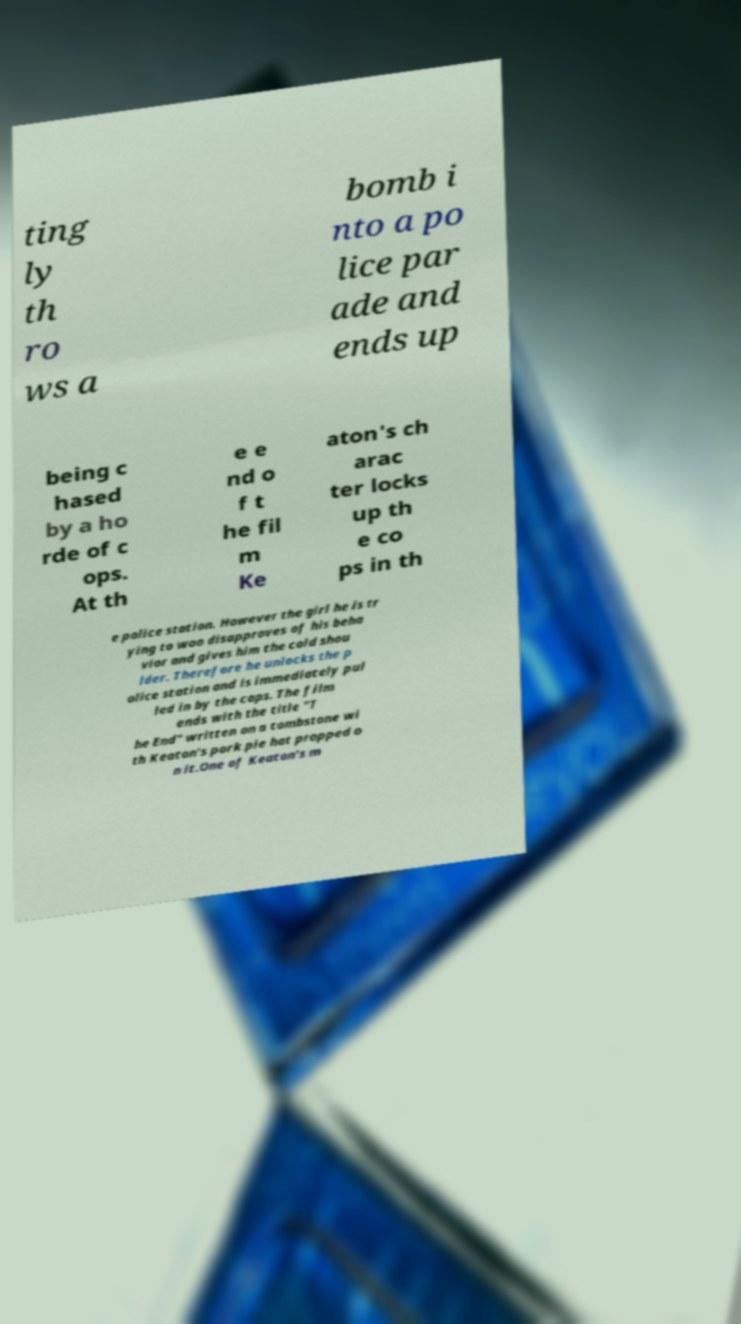Can you accurately transcribe the text from the provided image for me? ting ly th ro ws a bomb i nto a po lice par ade and ends up being c hased by a ho rde of c ops. At th e e nd o f t he fil m Ke aton's ch arac ter locks up th e co ps in th e police station. However the girl he is tr ying to woo disapproves of his beha vior and gives him the cold shou lder. Therefore he unlocks the p olice station and is immediately pul led in by the cops. The film ends with the title "T he End" written on a tombstone wi th Keaton's pork pie hat propped o n it.One of Keaton's m 